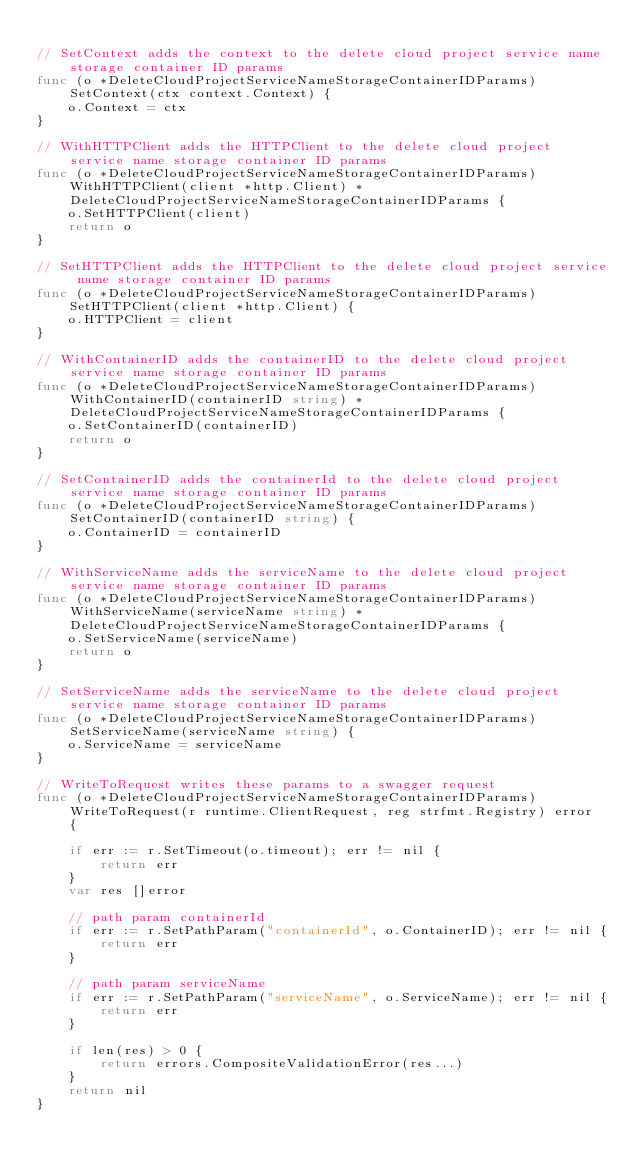<code> <loc_0><loc_0><loc_500><loc_500><_Go_>
// SetContext adds the context to the delete cloud project service name storage container ID params
func (o *DeleteCloudProjectServiceNameStorageContainerIDParams) SetContext(ctx context.Context) {
	o.Context = ctx
}

// WithHTTPClient adds the HTTPClient to the delete cloud project service name storage container ID params
func (o *DeleteCloudProjectServiceNameStorageContainerIDParams) WithHTTPClient(client *http.Client) *DeleteCloudProjectServiceNameStorageContainerIDParams {
	o.SetHTTPClient(client)
	return o
}

// SetHTTPClient adds the HTTPClient to the delete cloud project service name storage container ID params
func (o *DeleteCloudProjectServiceNameStorageContainerIDParams) SetHTTPClient(client *http.Client) {
	o.HTTPClient = client
}

// WithContainerID adds the containerID to the delete cloud project service name storage container ID params
func (o *DeleteCloudProjectServiceNameStorageContainerIDParams) WithContainerID(containerID string) *DeleteCloudProjectServiceNameStorageContainerIDParams {
	o.SetContainerID(containerID)
	return o
}

// SetContainerID adds the containerId to the delete cloud project service name storage container ID params
func (o *DeleteCloudProjectServiceNameStorageContainerIDParams) SetContainerID(containerID string) {
	o.ContainerID = containerID
}

// WithServiceName adds the serviceName to the delete cloud project service name storage container ID params
func (o *DeleteCloudProjectServiceNameStorageContainerIDParams) WithServiceName(serviceName string) *DeleteCloudProjectServiceNameStorageContainerIDParams {
	o.SetServiceName(serviceName)
	return o
}

// SetServiceName adds the serviceName to the delete cloud project service name storage container ID params
func (o *DeleteCloudProjectServiceNameStorageContainerIDParams) SetServiceName(serviceName string) {
	o.ServiceName = serviceName
}

// WriteToRequest writes these params to a swagger request
func (o *DeleteCloudProjectServiceNameStorageContainerIDParams) WriteToRequest(r runtime.ClientRequest, reg strfmt.Registry) error {

	if err := r.SetTimeout(o.timeout); err != nil {
		return err
	}
	var res []error

	// path param containerId
	if err := r.SetPathParam("containerId", o.ContainerID); err != nil {
		return err
	}

	// path param serviceName
	if err := r.SetPathParam("serviceName", o.ServiceName); err != nil {
		return err
	}

	if len(res) > 0 {
		return errors.CompositeValidationError(res...)
	}
	return nil
}
</code> 